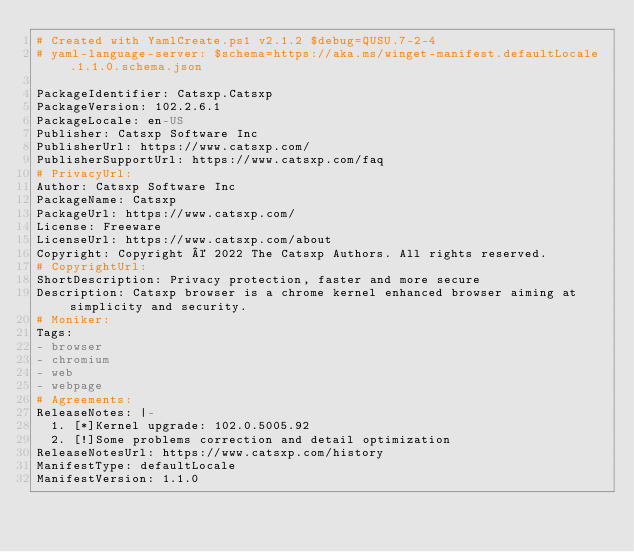Convert code to text. <code><loc_0><loc_0><loc_500><loc_500><_YAML_># Created with YamlCreate.ps1 v2.1.2 $debug=QUSU.7-2-4
# yaml-language-server: $schema=https://aka.ms/winget-manifest.defaultLocale.1.1.0.schema.json

PackageIdentifier: Catsxp.Catsxp
PackageVersion: 102.2.6.1
PackageLocale: en-US
Publisher: Catsxp Software Inc
PublisherUrl: https://www.catsxp.com/
PublisherSupportUrl: https://www.catsxp.com/faq
# PrivacyUrl: 
Author: Catsxp Software Inc
PackageName: Catsxp
PackageUrl: https://www.catsxp.com/
License: Freeware
LicenseUrl: https://www.catsxp.com/about
Copyright: Copyright © 2022 The Catsxp Authors. All rights reserved.
# CopyrightUrl: 
ShortDescription: Privacy protection, faster and more secure
Description: Catsxp browser is a chrome kernel enhanced browser aiming at simplicity and security.
# Moniker: 
Tags:
- browser
- chromium
- web
- webpage
# Agreements: 
ReleaseNotes: |-
  1. [*]Kernel upgrade: 102.0.5005.92
  2. [!]Some problems correction and detail optimization
ReleaseNotesUrl: https://www.catsxp.com/history
ManifestType: defaultLocale
ManifestVersion: 1.1.0
</code> 